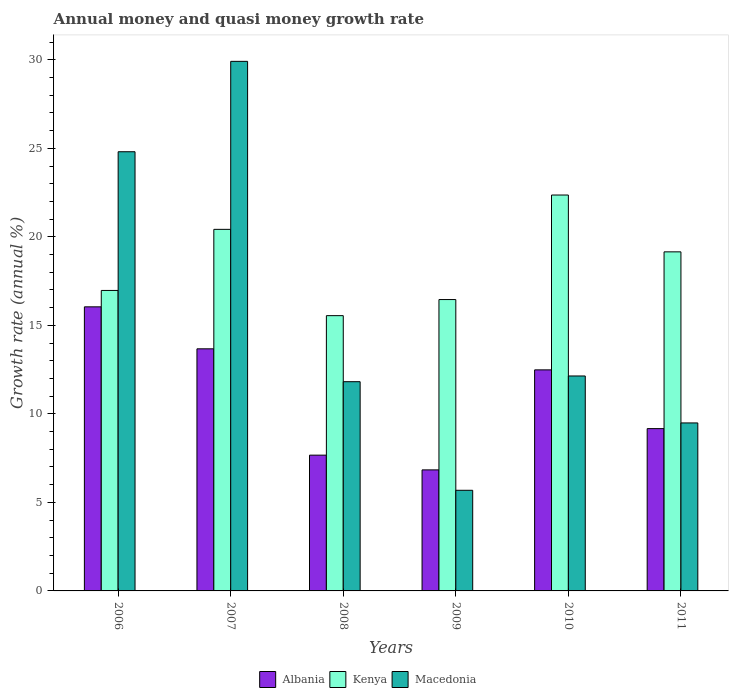How many different coloured bars are there?
Keep it short and to the point. 3. Are the number of bars on each tick of the X-axis equal?
Your response must be concise. Yes. How many bars are there on the 5th tick from the left?
Offer a very short reply. 3. What is the growth rate in Kenya in 2006?
Your answer should be compact. 16.97. Across all years, what is the maximum growth rate in Kenya?
Ensure brevity in your answer.  22.36. Across all years, what is the minimum growth rate in Macedonia?
Your answer should be compact. 5.68. In which year was the growth rate in Kenya maximum?
Give a very brief answer. 2010. In which year was the growth rate in Albania minimum?
Offer a terse response. 2009. What is the total growth rate in Macedonia in the graph?
Provide a succinct answer. 93.85. What is the difference between the growth rate in Kenya in 2006 and that in 2007?
Your answer should be compact. -3.45. What is the difference between the growth rate in Albania in 2007 and the growth rate in Kenya in 2006?
Your answer should be very brief. -3.3. What is the average growth rate in Kenya per year?
Offer a terse response. 18.49. In the year 2007, what is the difference between the growth rate in Kenya and growth rate in Macedonia?
Offer a terse response. -9.49. What is the ratio of the growth rate in Kenya in 2007 to that in 2010?
Give a very brief answer. 0.91. Is the growth rate in Kenya in 2010 less than that in 2011?
Your answer should be very brief. No. Is the difference between the growth rate in Kenya in 2007 and 2010 greater than the difference between the growth rate in Macedonia in 2007 and 2010?
Offer a terse response. No. What is the difference between the highest and the second highest growth rate in Albania?
Provide a succinct answer. 2.37. What is the difference between the highest and the lowest growth rate in Albania?
Keep it short and to the point. 9.21. What does the 3rd bar from the left in 2006 represents?
Your response must be concise. Macedonia. What does the 3rd bar from the right in 2008 represents?
Provide a short and direct response. Albania. Are all the bars in the graph horizontal?
Give a very brief answer. No. How many years are there in the graph?
Give a very brief answer. 6. What is the difference between two consecutive major ticks on the Y-axis?
Give a very brief answer. 5. Are the values on the major ticks of Y-axis written in scientific E-notation?
Offer a terse response. No. Does the graph contain any zero values?
Give a very brief answer. No. Where does the legend appear in the graph?
Ensure brevity in your answer.  Bottom center. What is the title of the graph?
Give a very brief answer. Annual money and quasi money growth rate. What is the label or title of the X-axis?
Your answer should be compact. Years. What is the label or title of the Y-axis?
Provide a succinct answer. Growth rate (annual %). What is the Growth rate (annual %) of Albania in 2006?
Your response must be concise. 16.05. What is the Growth rate (annual %) in Kenya in 2006?
Ensure brevity in your answer.  16.97. What is the Growth rate (annual %) of Macedonia in 2006?
Your response must be concise. 24.81. What is the Growth rate (annual %) in Albania in 2007?
Offer a terse response. 13.67. What is the Growth rate (annual %) of Kenya in 2007?
Offer a terse response. 20.42. What is the Growth rate (annual %) in Macedonia in 2007?
Provide a short and direct response. 29.91. What is the Growth rate (annual %) in Albania in 2008?
Ensure brevity in your answer.  7.67. What is the Growth rate (annual %) of Kenya in 2008?
Ensure brevity in your answer.  15.55. What is the Growth rate (annual %) of Macedonia in 2008?
Keep it short and to the point. 11.82. What is the Growth rate (annual %) of Albania in 2009?
Your answer should be very brief. 6.84. What is the Growth rate (annual %) of Kenya in 2009?
Make the answer very short. 16.46. What is the Growth rate (annual %) in Macedonia in 2009?
Keep it short and to the point. 5.68. What is the Growth rate (annual %) in Albania in 2010?
Keep it short and to the point. 12.49. What is the Growth rate (annual %) of Kenya in 2010?
Your answer should be compact. 22.36. What is the Growth rate (annual %) of Macedonia in 2010?
Offer a very short reply. 12.14. What is the Growth rate (annual %) of Albania in 2011?
Offer a terse response. 9.17. What is the Growth rate (annual %) in Kenya in 2011?
Keep it short and to the point. 19.15. What is the Growth rate (annual %) in Macedonia in 2011?
Offer a very short reply. 9.49. Across all years, what is the maximum Growth rate (annual %) in Albania?
Your answer should be compact. 16.05. Across all years, what is the maximum Growth rate (annual %) of Kenya?
Ensure brevity in your answer.  22.36. Across all years, what is the maximum Growth rate (annual %) of Macedonia?
Provide a succinct answer. 29.91. Across all years, what is the minimum Growth rate (annual %) of Albania?
Ensure brevity in your answer.  6.84. Across all years, what is the minimum Growth rate (annual %) in Kenya?
Your answer should be very brief. 15.55. Across all years, what is the minimum Growth rate (annual %) in Macedonia?
Give a very brief answer. 5.68. What is the total Growth rate (annual %) in Albania in the graph?
Provide a succinct answer. 65.88. What is the total Growth rate (annual %) in Kenya in the graph?
Your response must be concise. 110.91. What is the total Growth rate (annual %) in Macedonia in the graph?
Ensure brevity in your answer.  93.85. What is the difference between the Growth rate (annual %) in Albania in 2006 and that in 2007?
Offer a terse response. 2.37. What is the difference between the Growth rate (annual %) in Kenya in 2006 and that in 2007?
Ensure brevity in your answer.  -3.45. What is the difference between the Growth rate (annual %) in Macedonia in 2006 and that in 2007?
Ensure brevity in your answer.  -5.11. What is the difference between the Growth rate (annual %) of Albania in 2006 and that in 2008?
Offer a very short reply. 8.38. What is the difference between the Growth rate (annual %) of Kenya in 2006 and that in 2008?
Your response must be concise. 1.42. What is the difference between the Growth rate (annual %) in Macedonia in 2006 and that in 2008?
Keep it short and to the point. 12.99. What is the difference between the Growth rate (annual %) in Albania in 2006 and that in 2009?
Ensure brevity in your answer.  9.21. What is the difference between the Growth rate (annual %) in Kenya in 2006 and that in 2009?
Your answer should be compact. 0.51. What is the difference between the Growth rate (annual %) of Macedonia in 2006 and that in 2009?
Provide a succinct answer. 19.12. What is the difference between the Growth rate (annual %) in Albania in 2006 and that in 2010?
Ensure brevity in your answer.  3.56. What is the difference between the Growth rate (annual %) of Kenya in 2006 and that in 2010?
Make the answer very short. -5.39. What is the difference between the Growth rate (annual %) of Macedonia in 2006 and that in 2010?
Offer a very short reply. 12.67. What is the difference between the Growth rate (annual %) of Albania in 2006 and that in 2011?
Ensure brevity in your answer.  6.88. What is the difference between the Growth rate (annual %) in Kenya in 2006 and that in 2011?
Provide a succinct answer. -2.18. What is the difference between the Growth rate (annual %) of Macedonia in 2006 and that in 2011?
Provide a succinct answer. 15.32. What is the difference between the Growth rate (annual %) of Albania in 2007 and that in 2008?
Ensure brevity in your answer.  6.01. What is the difference between the Growth rate (annual %) of Kenya in 2007 and that in 2008?
Give a very brief answer. 4.87. What is the difference between the Growth rate (annual %) of Macedonia in 2007 and that in 2008?
Your answer should be compact. 18.09. What is the difference between the Growth rate (annual %) of Albania in 2007 and that in 2009?
Your response must be concise. 6.84. What is the difference between the Growth rate (annual %) in Kenya in 2007 and that in 2009?
Your answer should be compact. 3.97. What is the difference between the Growth rate (annual %) in Macedonia in 2007 and that in 2009?
Your answer should be very brief. 24.23. What is the difference between the Growth rate (annual %) in Albania in 2007 and that in 2010?
Keep it short and to the point. 1.19. What is the difference between the Growth rate (annual %) of Kenya in 2007 and that in 2010?
Your answer should be very brief. -1.94. What is the difference between the Growth rate (annual %) in Macedonia in 2007 and that in 2010?
Provide a succinct answer. 17.77. What is the difference between the Growth rate (annual %) of Albania in 2007 and that in 2011?
Offer a terse response. 4.51. What is the difference between the Growth rate (annual %) in Kenya in 2007 and that in 2011?
Your answer should be very brief. 1.27. What is the difference between the Growth rate (annual %) of Macedonia in 2007 and that in 2011?
Your answer should be very brief. 20.42. What is the difference between the Growth rate (annual %) in Albania in 2008 and that in 2009?
Provide a short and direct response. 0.83. What is the difference between the Growth rate (annual %) in Kenya in 2008 and that in 2009?
Your response must be concise. -0.91. What is the difference between the Growth rate (annual %) in Macedonia in 2008 and that in 2009?
Offer a terse response. 6.13. What is the difference between the Growth rate (annual %) of Albania in 2008 and that in 2010?
Give a very brief answer. -4.82. What is the difference between the Growth rate (annual %) in Kenya in 2008 and that in 2010?
Give a very brief answer. -6.81. What is the difference between the Growth rate (annual %) of Macedonia in 2008 and that in 2010?
Offer a very short reply. -0.32. What is the difference between the Growth rate (annual %) of Albania in 2008 and that in 2011?
Make the answer very short. -1.5. What is the difference between the Growth rate (annual %) in Kenya in 2008 and that in 2011?
Your answer should be very brief. -3.6. What is the difference between the Growth rate (annual %) in Macedonia in 2008 and that in 2011?
Make the answer very short. 2.33. What is the difference between the Growth rate (annual %) of Albania in 2009 and that in 2010?
Offer a terse response. -5.65. What is the difference between the Growth rate (annual %) of Kenya in 2009 and that in 2010?
Your answer should be compact. -5.9. What is the difference between the Growth rate (annual %) of Macedonia in 2009 and that in 2010?
Your response must be concise. -6.46. What is the difference between the Growth rate (annual %) in Albania in 2009 and that in 2011?
Provide a short and direct response. -2.33. What is the difference between the Growth rate (annual %) in Kenya in 2009 and that in 2011?
Your response must be concise. -2.69. What is the difference between the Growth rate (annual %) in Macedonia in 2009 and that in 2011?
Offer a very short reply. -3.8. What is the difference between the Growth rate (annual %) in Albania in 2010 and that in 2011?
Keep it short and to the point. 3.32. What is the difference between the Growth rate (annual %) in Kenya in 2010 and that in 2011?
Ensure brevity in your answer.  3.21. What is the difference between the Growth rate (annual %) of Macedonia in 2010 and that in 2011?
Ensure brevity in your answer.  2.65. What is the difference between the Growth rate (annual %) of Albania in 2006 and the Growth rate (annual %) of Kenya in 2007?
Offer a terse response. -4.38. What is the difference between the Growth rate (annual %) in Albania in 2006 and the Growth rate (annual %) in Macedonia in 2007?
Your answer should be very brief. -13.87. What is the difference between the Growth rate (annual %) of Kenya in 2006 and the Growth rate (annual %) of Macedonia in 2007?
Give a very brief answer. -12.94. What is the difference between the Growth rate (annual %) in Albania in 2006 and the Growth rate (annual %) in Kenya in 2008?
Offer a very short reply. 0.5. What is the difference between the Growth rate (annual %) in Albania in 2006 and the Growth rate (annual %) in Macedonia in 2008?
Give a very brief answer. 4.23. What is the difference between the Growth rate (annual %) of Kenya in 2006 and the Growth rate (annual %) of Macedonia in 2008?
Keep it short and to the point. 5.15. What is the difference between the Growth rate (annual %) of Albania in 2006 and the Growth rate (annual %) of Kenya in 2009?
Provide a succinct answer. -0.41. What is the difference between the Growth rate (annual %) of Albania in 2006 and the Growth rate (annual %) of Macedonia in 2009?
Offer a terse response. 10.36. What is the difference between the Growth rate (annual %) in Kenya in 2006 and the Growth rate (annual %) in Macedonia in 2009?
Your response must be concise. 11.29. What is the difference between the Growth rate (annual %) of Albania in 2006 and the Growth rate (annual %) of Kenya in 2010?
Give a very brief answer. -6.32. What is the difference between the Growth rate (annual %) in Albania in 2006 and the Growth rate (annual %) in Macedonia in 2010?
Keep it short and to the point. 3.9. What is the difference between the Growth rate (annual %) of Kenya in 2006 and the Growth rate (annual %) of Macedonia in 2010?
Provide a short and direct response. 4.83. What is the difference between the Growth rate (annual %) of Albania in 2006 and the Growth rate (annual %) of Kenya in 2011?
Ensure brevity in your answer.  -3.11. What is the difference between the Growth rate (annual %) in Albania in 2006 and the Growth rate (annual %) in Macedonia in 2011?
Provide a short and direct response. 6.56. What is the difference between the Growth rate (annual %) in Kenya in 2006 and the Growth rate (annual %) in Macedonia in 2011?
Give a very brief answer. 7.48. What is the difference between the Growth rate (annual %) of Albania in 2007 and the Growth rate (annual %) of Kenya in 2008?
Your answer should be compact. -1.87. What is the difference between the Growth rate (annual %) in Albania in 2007 and the Growth rate (annual %) in Macedonia in 2008?
Offer a terse response. 1.86. What is the difference between the Growth rate (annual %) of Kenya in 2007 and the Growth rate (annual %) of Macedonia in 2008?
Provide a succinct answer. 8.6. What is the difference between the Growth rate (annual %) in Albania in 2007 and the Growth rate (annual %) in Kenya in 2009?
Your response must be concise. -2.78. What is the difference between the Growth rate (annual %) in Albania in 2007 and the Growth rate (annual %) in Macedonia in 2009?
Ensure brevity in your answer.  7.99. What is the difference between the Growth rate (annual %) in Kenya in 2007 and the Growth rate (annual %) in Macedonia in 2009?
Offer a very short reply. 14.74. What is the difference between the Growth rate (annual %) of Albania in 2007 and the Growth rate (annual %) of Kenya in 2010?
Your answer should be compact. -8.69. What is the difference between the Growth rate (annual %) in Albania in 2007 and the Growth rate (annual %) in Macedonia in 2010?
Provide a short and direct response. 1.53. What is the difference between the Growth rate (annual %) in Kenya in 2007 and the Growth rate (annual %) in Macedonia in 2010?
Provide a succinct answer. 8.28. What is the difference between the Growth rate (annual %) of Albania in 2007 and the Growth rate (annual %) of Kenya in 2011?
Keep it short and to the point. -5.48. What is the difference between the Growth rate (annual %) in Albania in 2007 and the Growth rate (annual %) in Macedonia in 2011?
Provide a short and direct response. 4.19. What is the difference between the Growth rate (annual %) in Kenya in 2007 and the Growth rate (annual %) in Macedonia in 2011?
Offer a terse response. 10.93. What is the difference between the Growth rate (annual %) of Albania in 2008 and the Growth rate (annual %) of Kenya in 2009?
Offer a very short reply. -8.79. What is the difference between the Growth rate (annual %) of Albania in 2008 and the Growth rate (annual %) of Macedonia in 2009?
Make the answer very short. 1.98. What is the difference between the Growth rate (annual %) of Kenya in 2008 and the Growth rate (annual %) of Macedonia in 2009?
Provide a succinct answer. 9.86. What is the difference between the Growth rate (annual %) in Albania in 2008 and the Growth rate (annual %) in Kenya in 2010?
Give a very brief answer. -14.69. What is the difference between the Growth rate (annual %) of Albania in 2008 and the Growth rate (annual %) of Macedonia in 2010?
Your answer should be very brief. -4.47. What is the difference between the Growth rate (annual %) of Kenya in 2008 and the Growth rate (annual %) of Macedonia in 2010?
Make the answer very short. 3.41. What is the difference between the Growth rate (annual %) of Albania in 2008 and the Growth rate (annual %) of Kenya in 2011?
Offer a very short reply. -11.48. What is the difference between the Growth rate (annual %) of Albania in 2008 and the Growth rate (annual %) of Macedonia in 2011?
Keep it short and to the point. -1.82. What is the difference between the Growth rate (annual %) in Kenya in 2008 and the Growth rate (annual %) in Macedonia in 2011?
Provide a short and direct response. 6.06. What is the difference between the Growth rate (annual %) of Albania in 2009 and the Growth rate (annual %) of Kenya in 2010?
Offer a terse response. -15.53. What is the difference between the Growth rate (annual %) of Albania in 2009 and the Growth rate (annual %) of Macedonia in 2010?
Ensure brevity in your answer.  -5.3. What is the difference between the Growth rate (annual %) in Kenya in 2009 and the Growth rate (annual %) in Macedonia in 2010?
Your response must be concise. 4.32. What is the difference between the Growth rate (annual %) of Albania in 2009 and the Growth rate (annual %) of Kenya in 2011?
Your answer should be compact. -12.32. What is the difference between the Growth rate (annual %) of Albania in 2009 and the Growth rate (annual %) of Macedonia in 2011?
Your answer should be compact. -2.65. What is the difference between the Growth rate (annual %) of Kenya in 2009 and the Growth rate (annual %) of Macedonia in 2011?
Make the answer very short. 6.97. What is the difference between the Growth rate (annual %) in Albania in 2010 and the Growth rate (annual %) in Kenya in 2011?
Make the answer very short. -6.67. What is the difference between the Growth rate (annual %) in Albania in 2010 and the Growth rate (annual %) in Macedonia in 2011?
Provide a succinct answer. 3. What is the difference between the Growth rate (annual %) in Kenya in 2010 and the Growth rate (annual %) in Macedonia in 2011?
Your answer should be very brief. 12.87. What is the average Growth rate (annual %) in Albania per year?
Keep it short and to the point. 10.98. What is the average Growth rate (annual %) in Kenya per year?
Offer a very short reply. 18.49. What is the average Growth rate (annual %) of Macedonia per year?
Keep it short and to the point. 15.64. In the year 2006, what is the difference between the Growth rate (annual %) in Albania and Growth rate (annual %) in Kenya?
Your answer should be compact. -0.93. In the year 2006, what is the difference between the Growth rate (annual %) of Albania and Growth rate (annual %) of Macedonia?
Your answer should be compact. -8.76. In the year 2006, what is the difference between the Growth rate (annual %) of Kenya and Growth rate (annual %) of Macedonia?
Your answer should be very brief. -7.83. In the year 2007, what is the difference between the Growth rate (annual %) in Albania and Growth rate (annual %) in Kenya?
Your answer should be compact. -6.75. In the year 2007, what is the difference between the Growth rate (annual %) of Albania and Growth rate (annual %) of Macedonia?
Provide a succinct answer. -16.24. In the year 2007, what is the difference between the Growth rate (annual %) of Kenya and Growth rate (annual %) of Macedonia?
Offer a terse response. -9.49. In the year 2008, what is the difference between the Growth rate (annual %) in Albania and Growth rate (annual %) in Kenya?
Make the answer very short. -7.88. In the year 2008, what is the difference between the Growth rate (annual %) in Albania and Growth rate (annual %) in Macedonia?
Offer a terse response. -4.15. In the year 2008, what is the difference between the Growth rate (annual %) of Kenya and Growth rate (annual %) of Macedonia?
Keep it short and to the point. 3.73. In the year 2009, what is the difference between the Growth rate (annual %) in Albania and Growth rate (annual %) in Kenya?
Your response must be concise. -9.62. In the year 2009, what is the difference between the Growth rate (annual %) of Albania and Growth rate (annual %) of Macedonia?
Ensure brevity in your answer.  1.15. In the year 2009, what is the difference between the Growth rate (annual %) of Kenya and Growth rate (annual %) of Macedonia?
Offer a terse response. 10.77. In the year 2010, what is the difference between the Growth rate (annual %) of Albania and Growth rate (annual %) of Kenya?
Ensure brevity in your answer.  -9.88. In the year 2010, what is the difference between the Growth rate (annual %) of Albania and Growth rate (annual %) of Macedonia?
Your answer should be very brief. 0.35. In the year 2010, what is the difference between the Growth rate (annual %) of Kenya and Growth rate (annual %) of Macedonia?
Your response must be concise. 10.22. In the year 2011, what is the difference between the Growth rate (annual %) in Albania and Growth rate (annual %) in Kenya?
Keep it short and to the point. -9.98. In the year 2011, what is the difference between the Growth rate (annual %) of Albania and Growth rate (annual %) of Macedonia?
Provide a succinct answer. -0.32. In the year 2011, what is the difference between the Growth rate (annual %) of Kenya and Growth rate (annual %) of Macedonia?
Make the answer very short. 9.66. What is the ratio of the Growth rate (annual %) in Albania in 2006 to that in 2007?
Give a very brief answer. 1.17. What is the ratio of the Growth rate (annual %) in Kenya in 2006 to that in 2007?
Your answer should be compact. 0.83. What is the ratio of the Growth rate (annual %) in Macedonia in 2006 to that in 2007?
Your response must be concise. 0.83. What is the ratio of the Growth rate (annual %) in Albania in 2006 to that in 2008?
Provide a short and direct response. 2.09. What is the ratio of the Growth rate (annual %) in Kenya in 2006 to that in 2008?
Give a very brief answer. 1.09. What is the ratio of the Growth rate (annual %) of Macedonia in 2006 to that in 2008?
Your answer should be compact. 2.1. What is the ratio of the Growth rate (annual %) of Albania in 2006 to that in 2009?
Make the answer very short. 2.35. What is the ratio of the Growth rate (annual %) of Kenya in 2006 to that in 2009?
Make the answer very short. 1.03. What is the ratio of the Growth rate (annual %) of Macedonia in 2006 to that in 2009?
Give a very brief answer. 4.36. What is the ratio of the Growth rate (annual %) in Albania in 2006 to that in 2010?
Keep it short and to the point. 1.29. What is the ratio of the Growth rate (annual %) in Kenya in 2006 to that in 2010?
Give a very brief answer. 0.76. What is the ratio of the Growth rate (annual %) of Macedonia in 2006 to that in 2010?
Offer a terse response. 2.04. What is the ratio of the Growth rate (annual %) in Albania in 2006 to that in 2011?
Offer a very short reply. 1.75. What is the ratio of the Growth rate (annual %) in Kenya in 2006 to that in 2011?
Provide a succinct answer. 0.89. What is the ratio of the Growth rate (annual %) of Macedonia in 2006 to that in 2011?
Your answer should be very brief. 2.61. What is the ratio of the Growth rate (annual %) of Albania in 2007 to that in 2008?
Your response must be concise. 1.78. What is the ratio of the Growth rate (annual %) in Kenya in 2007 to that in 2008?
Offer a terse response. 1.31. What is the ratio of the Growth rate (annual %) in Macedonia in 2007 to that in 2008?
Provide a short and direct response. 2.53. What is the ratio of the Growth rate (annual %) of Albania in 2007 to that in 2009?
Keep it short and to the point. 2. What is the ratio of the Growth rate (annual %) in Kenya in 2007 to that in 2009?
Make the answer very short. 1.24. What is the ratio of the Growth rate (annual %) of Macedonia in 2007 to that in 2009?
Offer a terse response. 5.26. What is the ratio of the Growth rate (annual %) of Albania in 2007 to that in 2010?
Your answer should be very brief. 1.1. What is the ratio of the Growth rate (annual %) in Kenya in 2007 to that in 2010?
Give a very brief answer. 0.91. What is the ratio of the Growth rate (annual %) in Macedonia in 2007 to that in 2010?
Give a very brief answer. 2.46. What is the ratio of the Growth rate (annual %) of Albania in 2007 to that in 2011?
Make the answer very short. 1.49. What is the ratio of the Growth rate (annual %) in Kenya in 2007 to that in 2011?
Keep it short and to the point. 1.07. What is the ratio of the Growth rate (annual %) in Macedonia in 2007 to that in 2011?
Provide a short and direct response. 3.15. What is the ratio of the Growth rate (annual %) of Albania in 2008 to that in 2009?
Your response must be concise. 1.12. What is the ratio of the Growth rate (annual %) of Kenya in 2008 to that in 2009?
Your answer should be compact. 0.94. What is the ratio of the Growth rate (annual %) of Macedonia in 2008 to that in 2009?
Keep it short and to the point. 2.08. What is the ratio of the Growth rate (annual %) in Albania in 2008 to that in 2010?
Make the answer very short. 0.61. What is the ratio of the Growth rate (annual %) in Kenya in 2008 to that in 2010?
Provide a succinct answer. 0.7. What is the ratio of the Growth rate (annual %) of Macedonia in 2008 to that in 2010?
Offer a very short reply. 0.97. What is the ratio of the Growth rate (annual %) of Albania in 2008 to that in 2011?
Offer a terse response. 0.84. What is the ratio of the Growth rate (annual %) in Kenya in 2008 to that in 2011?
Ensure brevity in your answer.  0.81. What is the ratio of the Growth rate (annual %) in Macedonia in 2008 to that in 2011?
Make the answer very short. 1.25. What is the ratio of the Growth rate (annual %) in Albania in 2009 to that in 2010?
Ensure brevity in your answer.  0.55. What is the ratio of the Growth rate (annual %) of Kenya in 2009 to that in 2010?
Keep it short and to the point. 0.74. What is the ratio of the Growth rate (annual %) in Macedonia in 2009 to that in 2010?
Give a very brief answer. 0.47. What is the ratio of the Growth rate (annual %) in Albania in 2009 to that in 2011?
Ensure brevity in your answer.  0.75. What is the ratio of the Growth rate (annual %) in Kenya in 2009 to that in 2011?
Your response must be concise. 0.86. What is the ratio of the Growth rate (annual %) of Macedonia in 2009 to that in 2011?
Keep it short and to the point. 0.6. What is the ratio of the Growth rate (annual %) of Albania in 2010 to that in 2011?
Offer a very short reply. 1.36. What is the ratio of the Growth rate (annual %) of Kenya in 2010 to that in 2011?
Ensure brevity in your answer.  1.17. What is the ratio of the Growth rate (annual %) of Macedonia in 2010 to that in 2011?
Your answer should be compact. 1.28. What is the difference between the highest and the second highest Growth rate (annual %) of Albania?
Provide a succinct answer. 2.37. What is the difference between the highest and the second highest Growth rate (annual %) of Kenya?
Make the answer very short. 1.94. What is the difference between the highest and the second highest Growth rate (annual %) of Macedonia?
Provide a succinct answer. 5.11. What is the difference between the highest and the lowest Growth rate (annual %) in Albania?
Provide a succinct answer. 9.21. What is the difference between the highest and the lowest Growth rate (annual %) of Kenya?
Offer a terse response. 6.81. What is the difference between the highest and the lowest Growth rate (annual %) of Macedonia?
Offer a terse response. 24.23. 